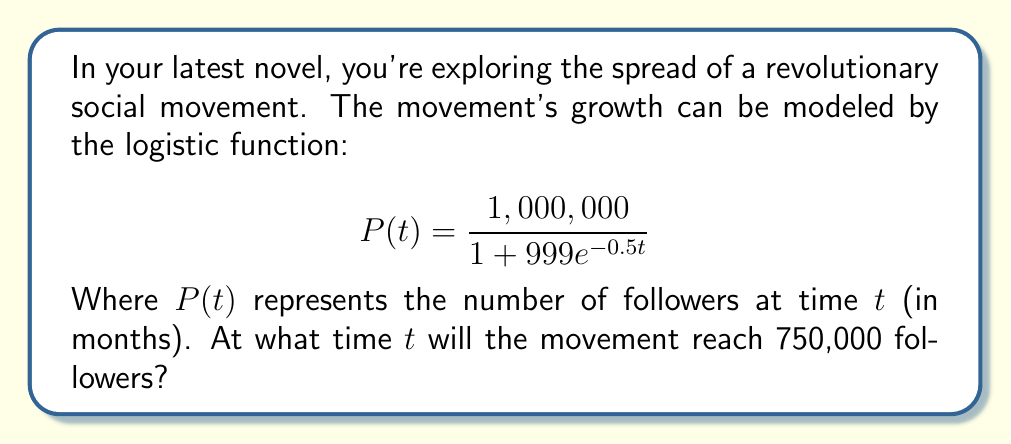Give your solution to this math problem. To solve this problem, we'll follow these steps:

1) The logistic function is given by:
   $$P(t) = \frac{1,000,000}{1 + 999e^{-0.5t}}$$

2) We want to find $t$ when $P(t) = 750,000$. So, let's set up the equation:
   $$750,000 = \frac{1,000,000}{1 + 999e^{-0.5t}}$$

3) Multiply both sides by $(1 + 999e^{-0.5t})$:
   $$750,000(1 + 999e^{-0.5t}) = 1,000,000$$

4) Expand the left side:
   $$750,000 + 749,250,000e^{-0.5t} = 1,000,000$$

5) Subtract 750,000 from both sides:
   $$749,250,000e^{-0.5t} = 250,000$$

6) Divide both sides by 749,250,000:
   $$e^{-0.5t} = \frac{1}{2,997}$$

7) Take the natural log of both sides:
   $$-0.5t = \ln(\frac{1}{2,997})$$

8) Multiply both sides by -2:
   $$t = -2\ln(\frac{1}{2,997}) = 2\ln(2,997)$$

9) Calculate the final value:
   $$t \approx 16.19$$
Answer: $16.19$ months 